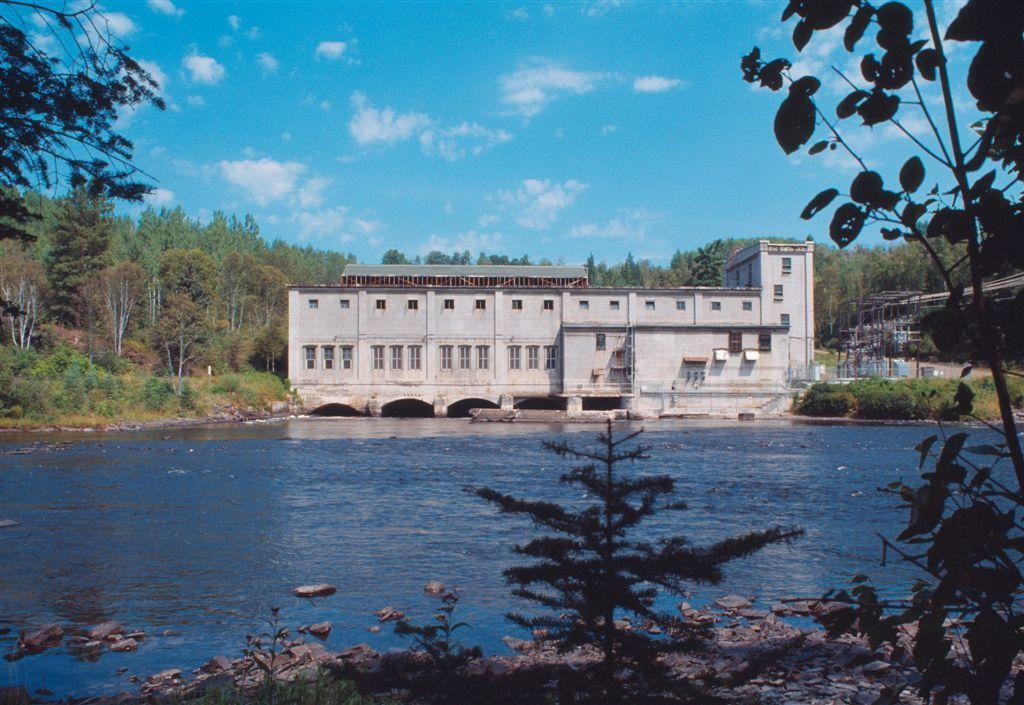What is the main structure in the center of the image? There is a building in the center of the image. What is located at the bottom of the image? There is water at the bottom of the image. What type of vegetation can be seen in the image? Trees are visible in the image. What part of the natural environment is visible in the background of the image? The sky is visible in the background of the image. Where is the sofa located in the image? There is no sofa present in the image. What type of scarecrow can be seen in the water at the bottom of the image? There are no scarecrows present in the image; it features water at the bottom. 